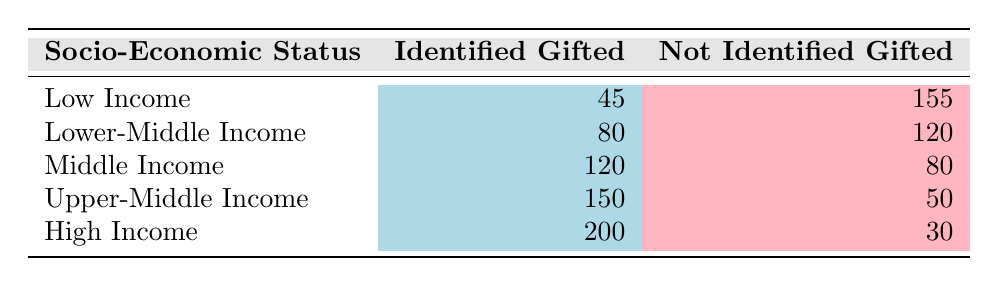What is the number of identified gifted children in the High Income group? According to the table, the High Income group has an "Identified Gifted" count of 200.
Answer: 200 What is the total number of identified gifted children across all socio-economic status groups? To find the total, we add the "Identified Gifted" values across all groups: 45 + 80 + 120 + 150 + 200 = 595.
Answer: 595 Are there more identified gifted children in Upper-Middle Income than in Middle Income? In the table, Upper-Middle Income has 150 identified gifted children, while Middle Income has 120. Since 150 is greater than 120, the answer is yes.
Answer: Yes What is the average number of not identified gifted children across all groups? The total for "Not Identified Gifted" is 155 + 120 + 80 + 50 + 30 = 435. Dividing this by the 5 groups gives an average of 435/5 = 87.
Answer: 87 How many more not identified gifted children are there in Low Income than in Upper-Middle Income? In Low Income, there are 155 not identified gifted children, and in Upper-Middle Income, there are 50. The difference is 155 - 50 = 105.
Answer: 105 Is the number of identified gifted children in Lower-Middle Income equal to that in Upper-Middle Income? The table shows 80 identified gifted children in Lower-Middle Income and 150 in Upper-Middle Income. Since 80 is not equal to 150, the answer is no.
Answer: No What proportion of identified gifted children comes from the High Income group? There are 200 identified gifted children in High Income and a total of 595 identified gifted children overall. The proportion is 200/595, which simplifies to approximately 0.336 or 33.6%.
Answer: 33.6% What is the difference between the number of identified gifted children in High Income and Low Income? Looking at the numbers from the table, High Income has 200 identified gifted children and Low Income has 45. The difference is 200 - 45 = 155.
Answer: 155 How many socio-economic status groups have more than 100 identified gifted children? By checking the table, we find that the groups with more than 100 identified gifted children are Middle Income (120), Upper-Middle Income (150), and High Income (200). That totals to 3 groups.
Answer: 3 